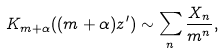Convert formula to latex. <formula><loc_0><loc_0><loc_500><loc_500>K _ { m + \alpha } ( ( m + \alpha ) z ^ { \prime } ) \sim \sum _ { n } \frac { X _ { n } } { m ^ { n } } ,</formula> 